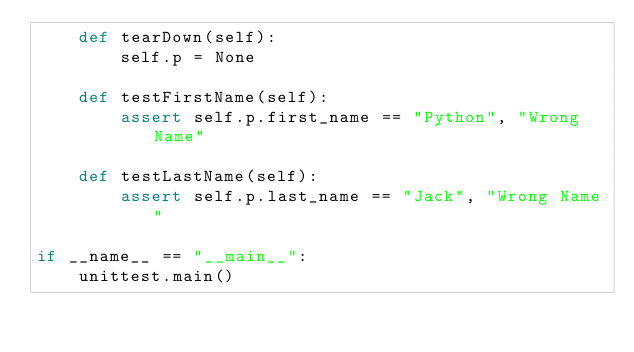Convert code to text. <code><loc_0><loc_0><loc_500><loc_500><_Python_>    def tearDown(self):
        self.p = None
        
    def testFirstName(self):
        assert self.p.first_name == "Python", "Wrong Name"
        
    def testLastName(self):
        assert self.p.last_name == "Jack", "Wrong Name"
        
if __name__ == "__main__":
    unittest.main()</code> 